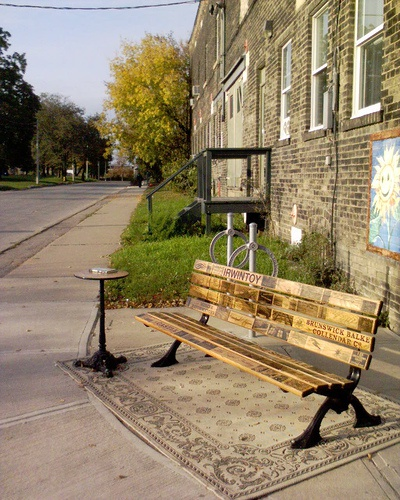Describe the objects in this image and their specific colors. I can see a bench in lavender, tan, black, and olive tones in this image. 